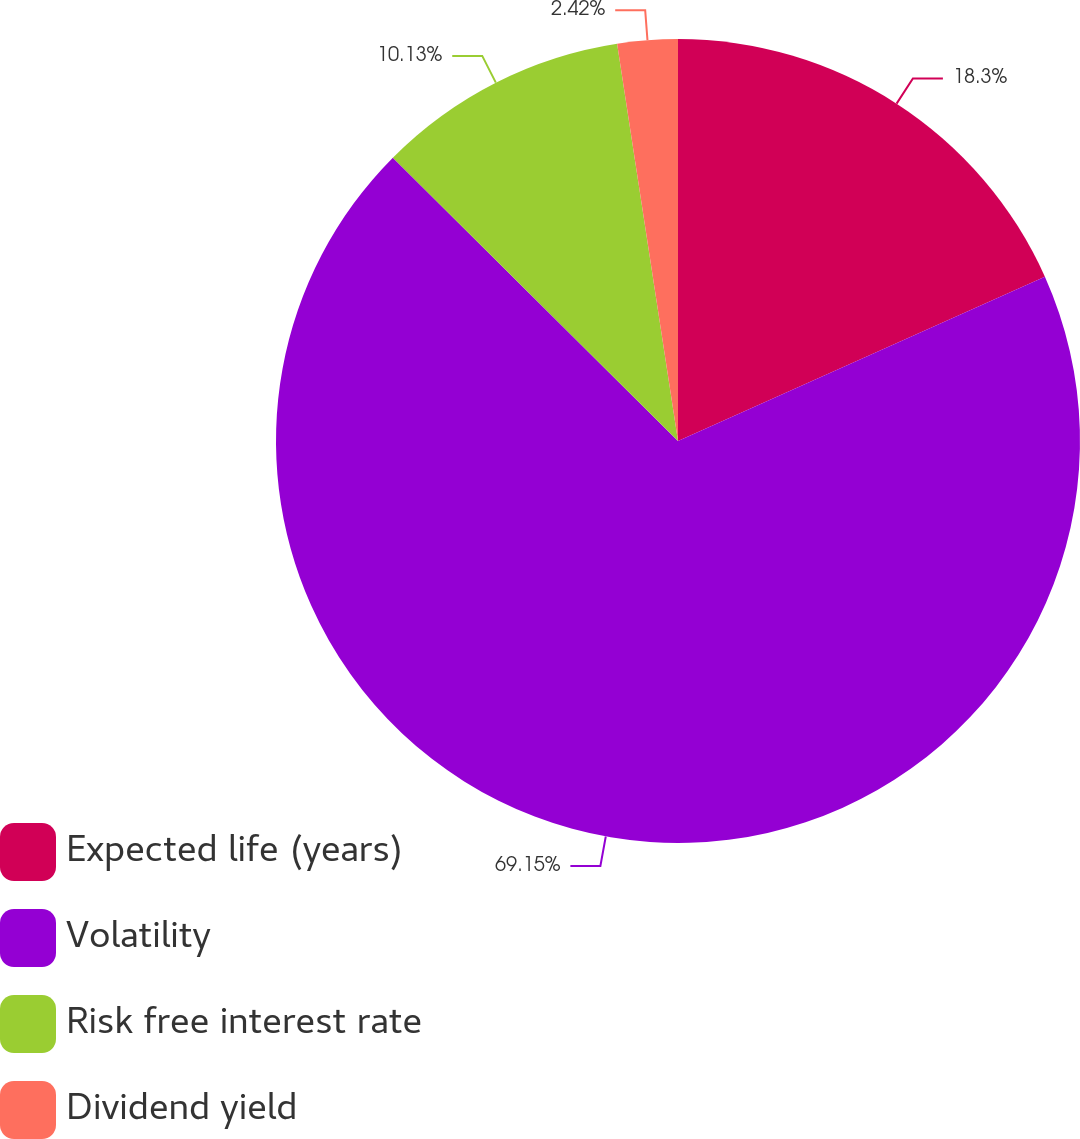Convert chart to OTSL. <chart><loc_0><loc_0><loc_500><loc_500><pie_chart><fcel>Expected life (years)<fcel>Volatility<fcel>Risk free interest rate<fcel>Dividend yield<nl><fcel>18.3%<fcel>69.15%<fcel>10.13%<fcel>2.42%<nl></chart> 